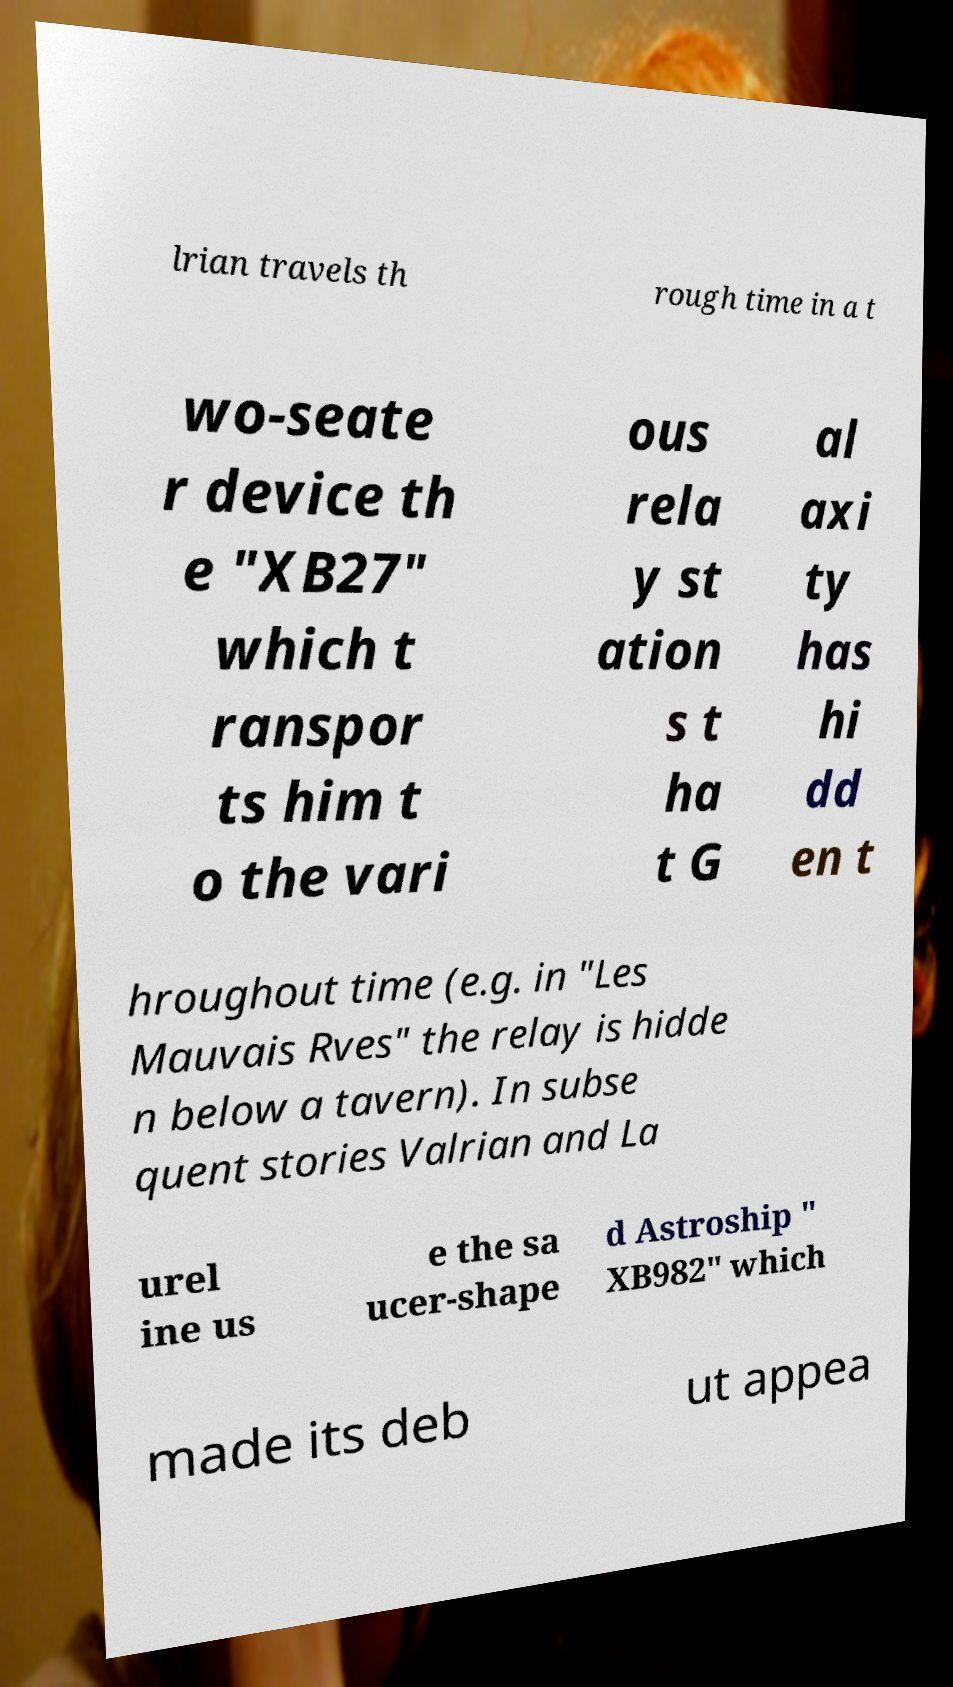What messages or text are displayed in this image? I need them in a readable, typed format. lrian travels th rough time in a t wo-seate r device th e "XB27" which t ranspor ts him t o the vari ous rela y st ation s t ha t G al axi ty has hi dd en t hroughout time (e.g. in "Les Mauvais Rves" the relay is hidde n below a tavern). In subse quent stories Valrian and La urel ine us e the sa ucer-shape d Astroship " XB982" which made its deb ut appea 